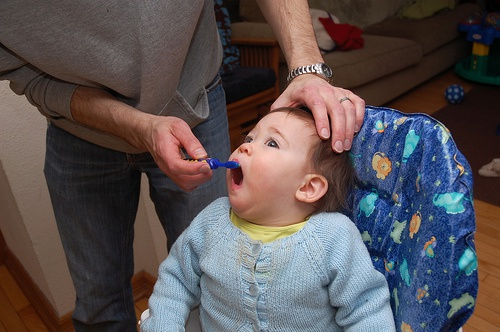Describe the objects in this image and their specific colors. I can see people in black, gray, maroon, and salmon tones, people in black, darkgray, lightblue, gray, and lightpink tones, chair in black, navy, darkblue, blue, and gray tones, couch in black, gray, and maroon tones, and couch in black, maroon, and gray tones in this image. 